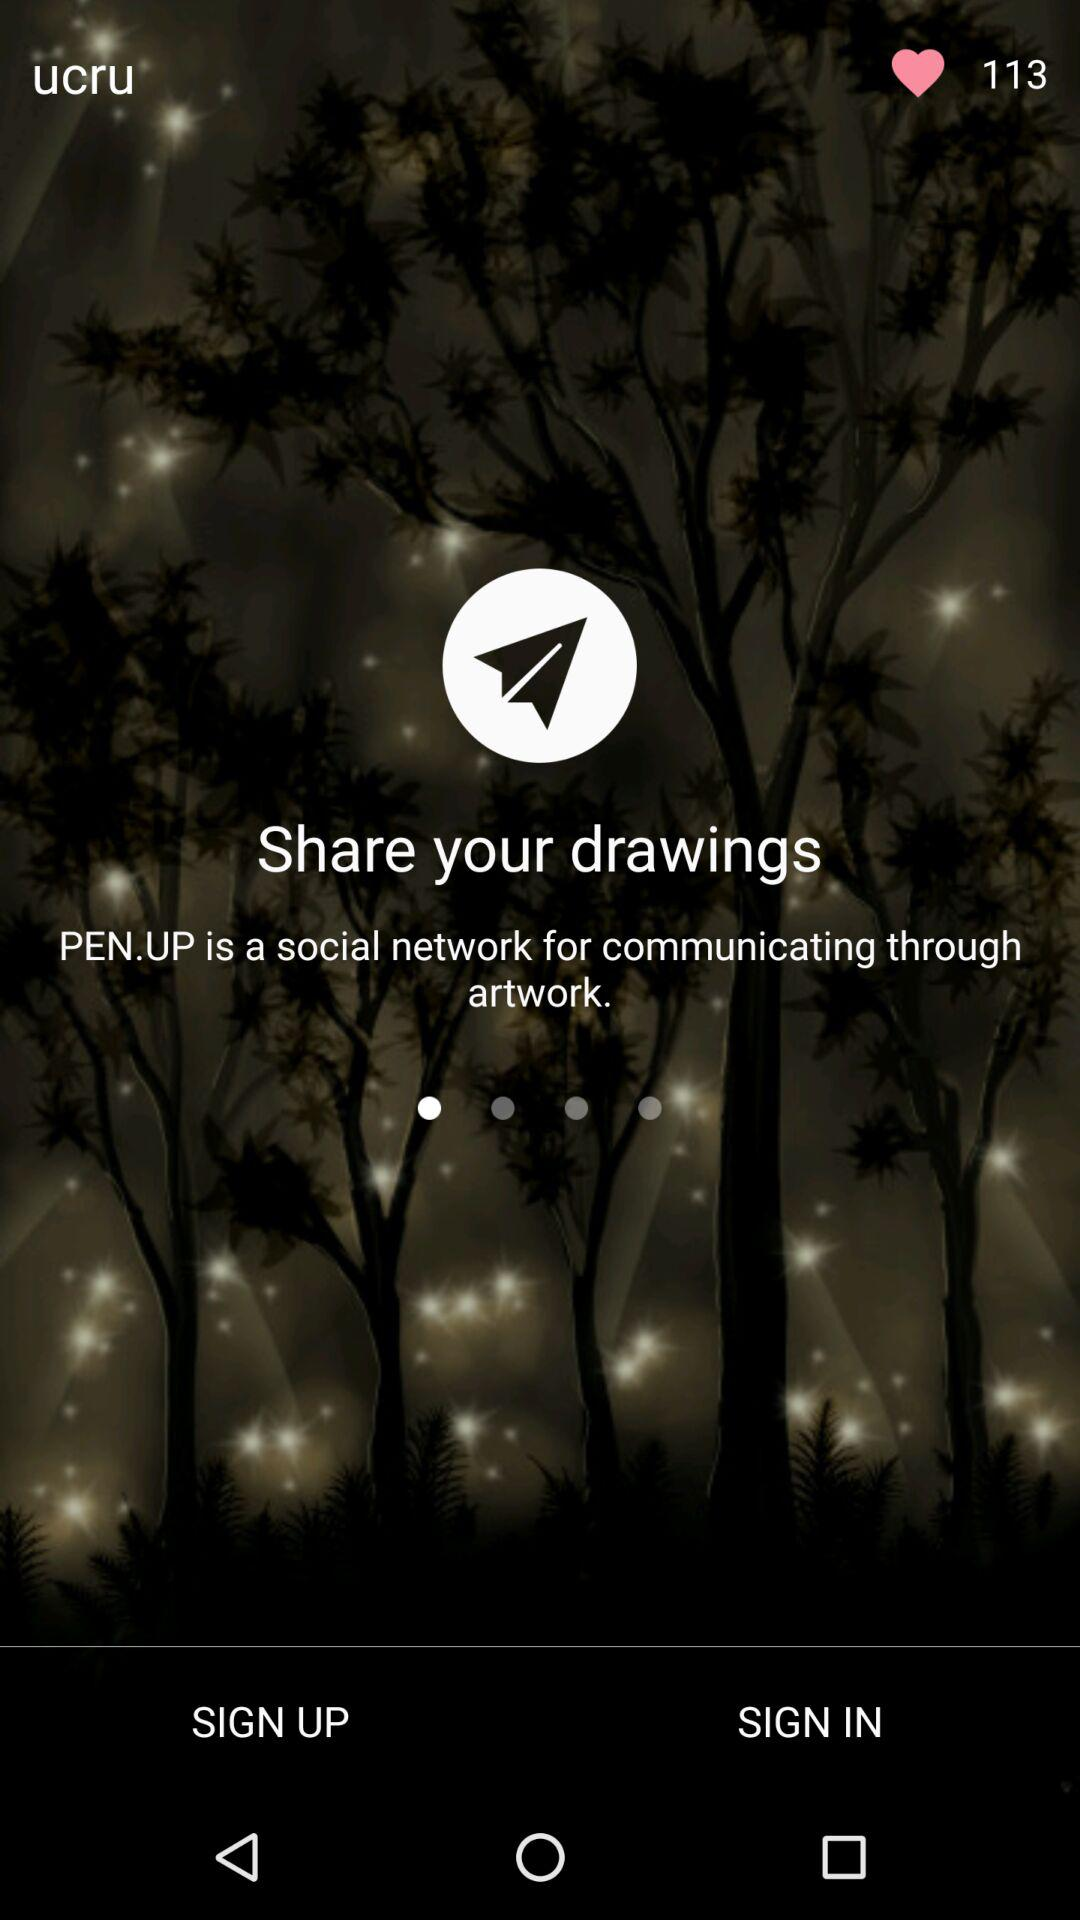What is the number of likes? The number of likes is 113. 